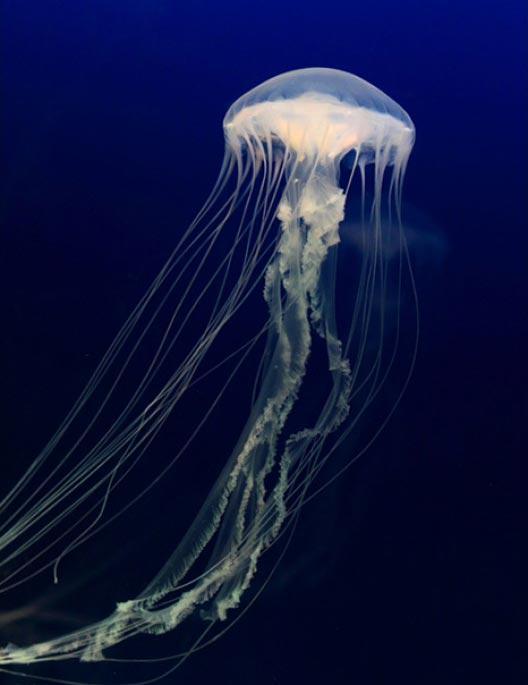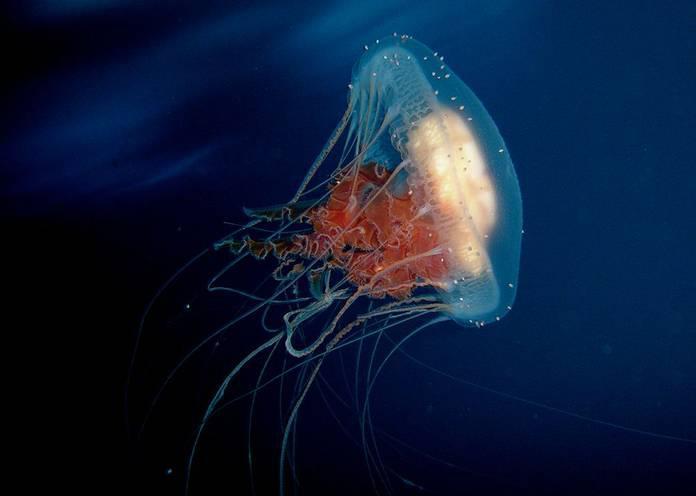The first image is the image on the left, the second image is the image on the right. For the images displayed, is the sentence "Both images show jellyfish with trailing tentacles." factually correct? Answer yes or no. Yes. 